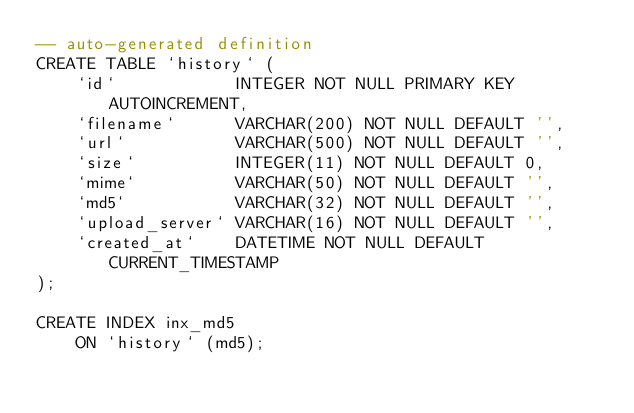Convert code to text. <code><loc_0><loc_0><loc_500><loc_500><_SQL_>-- auto-generated definition
CREATE TABLE `history` (
    `id`            INTEGER NOT NULL PRIMARY KEY AUTOINCREMENT,
    `filename`      VARCHAR(200) NOT NULL DEFAULT '',
    `url`           VARCHAR(500) NOT NULL DEFAULT '',
    `size`          INTEGER(11) NOT NULL DEFAULT 0,
    `mime`          VARCHAR(50) NOT NULL DEFAULT '',
    `md5`           VARCHAR(32) NOT NULL DEFAULT '',
    `upload_server` VARCHAR(16) NOT NULL DEFAULT '',
    `created_at`    DATETIME NOT NULL DEFAULT CURRENT_TIMESTAMP
);

CREATE INDEX inx_md5
    ON `history` (md5);

</code> 